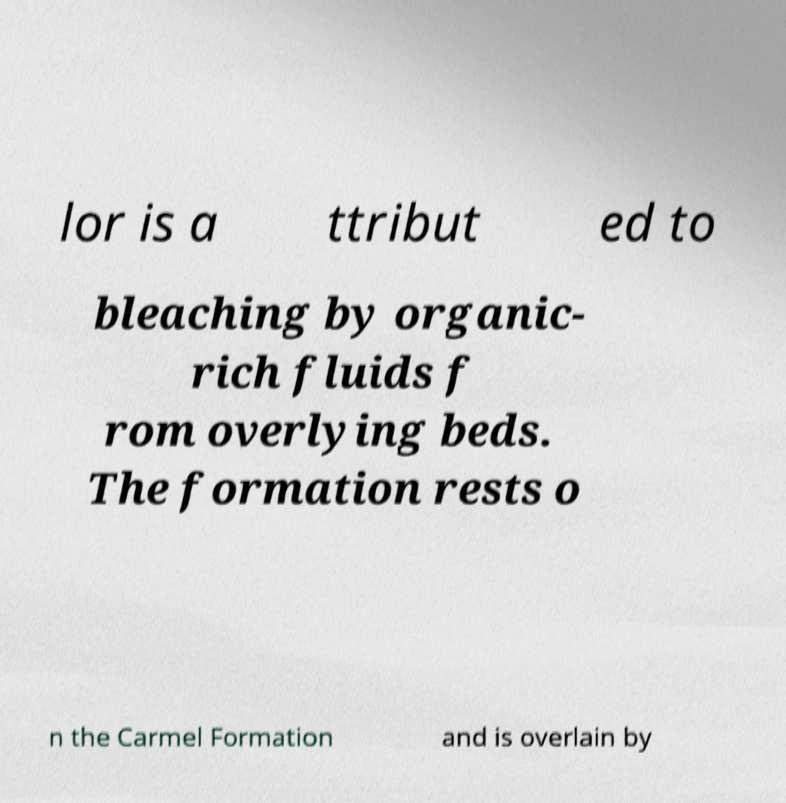Could you extract and type out the text from this image? lor is a ttribut ed to bleaching by organic- rich fluids f rom overlying beds. The formation rests o n the Carmel Formation and is overlain by 